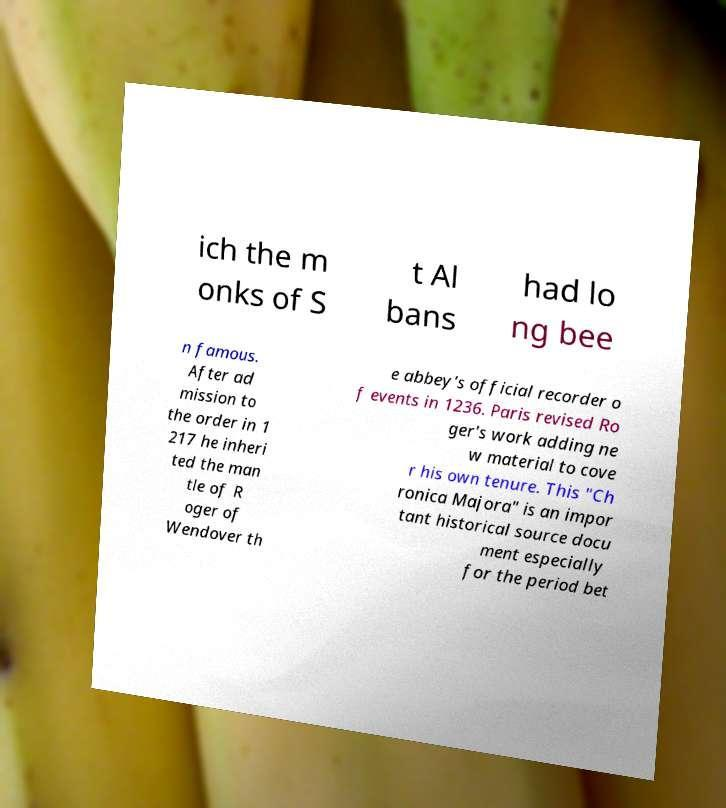Could you extract and type out the text from this image? ich the m onks of S t Al bans had lo ng bee n famous. After ad mission to the order in 1 217 he inheri ted the man tle of R oger of Wendover th e abbey's official recorder o f events in 1236. Paris revised Ro ger's work adding ne w material to cove r his own tenure. This "Ch ronica Majora" is an impor tant historical source docu ment especially for the period bet 